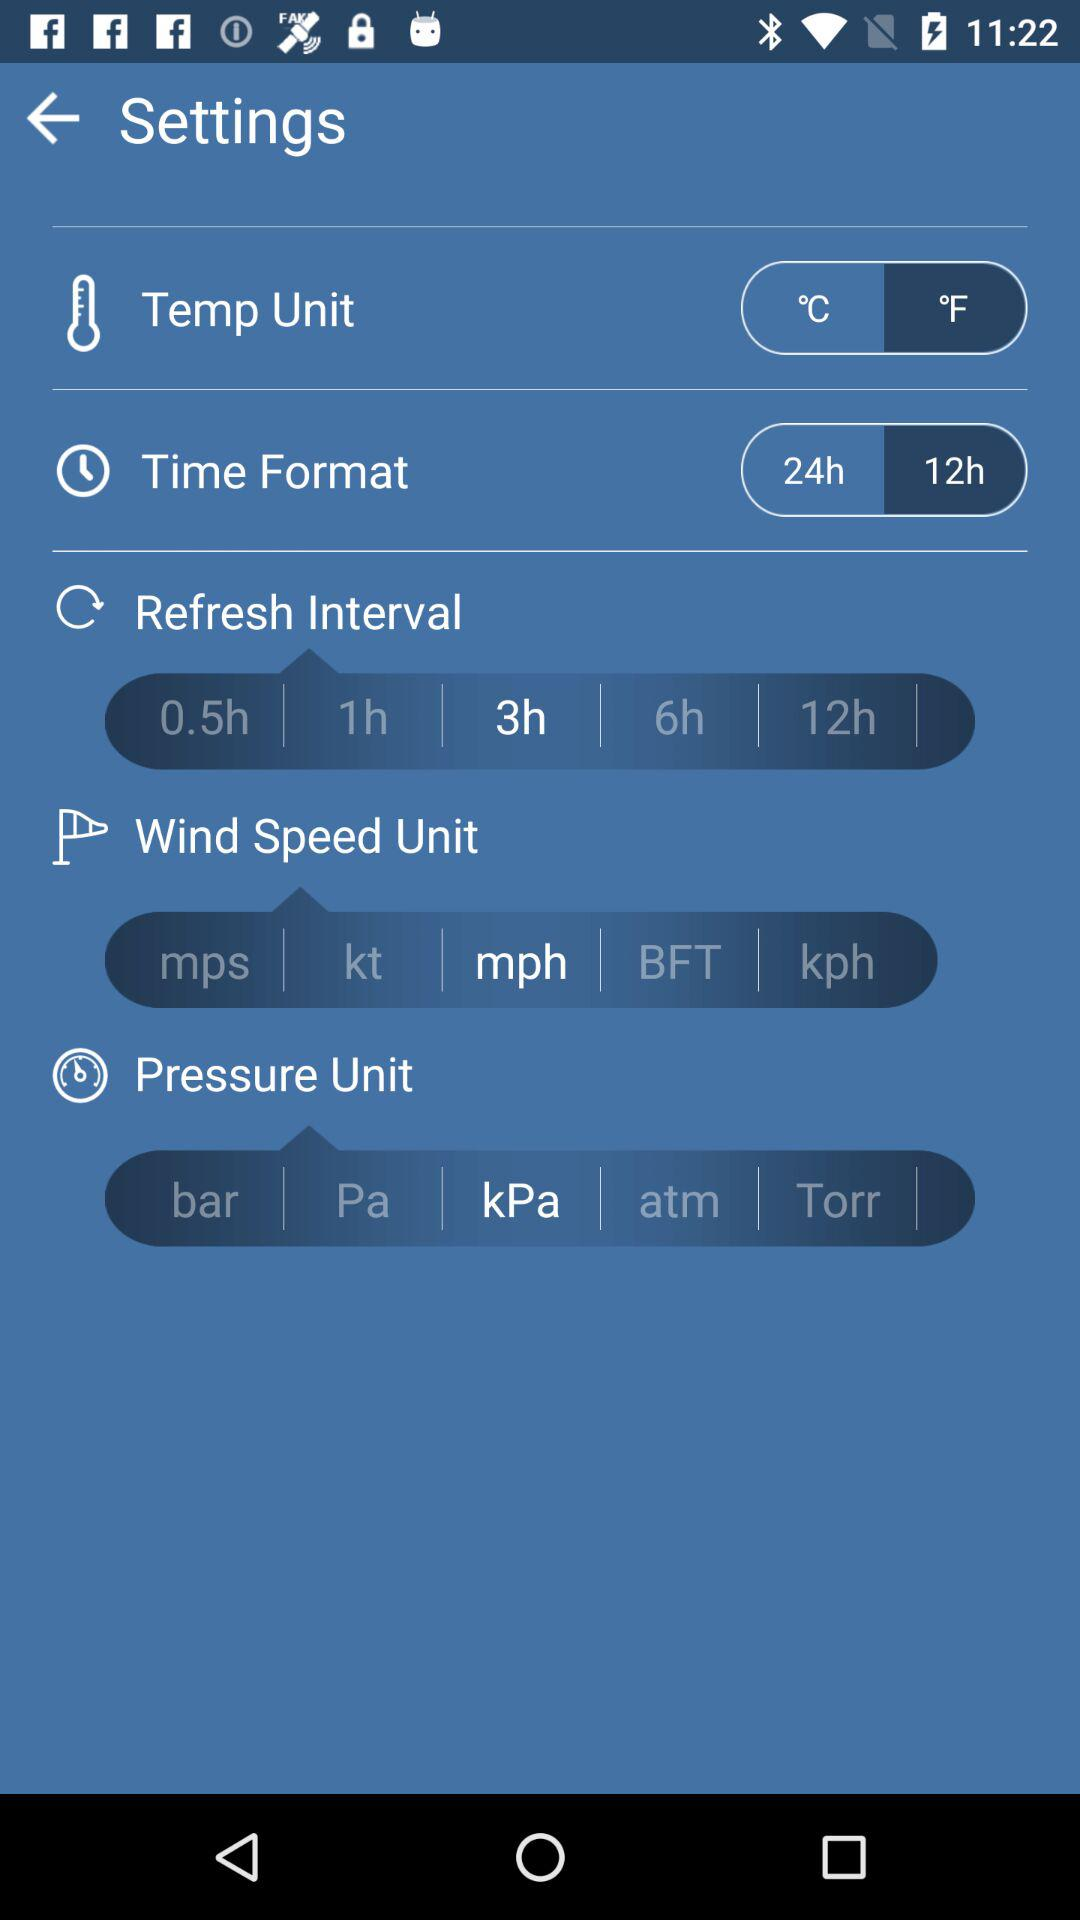What is the time format? The time format is 12 hours. 